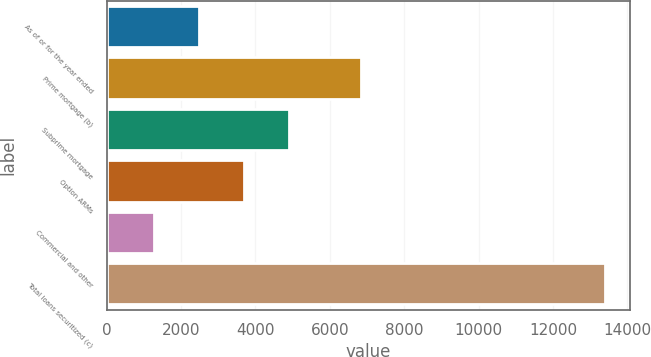Convert chart to OTSL. <chart><loc_0><loc_0><loc_500><loc_500><bar_chart><fcel>As of or for the year ended<fcel>Prime mortgage (b)<fcel>Subprime mortgage<fcel>Option ARMs<fcel>Commercial and other<fcel>Total loans securitized (c)<nl><fcel>2478.1<fcel>6850<fcel>4904.3<fcel>3691.2<fcel>1265<fcel>13396<nl></chart> 